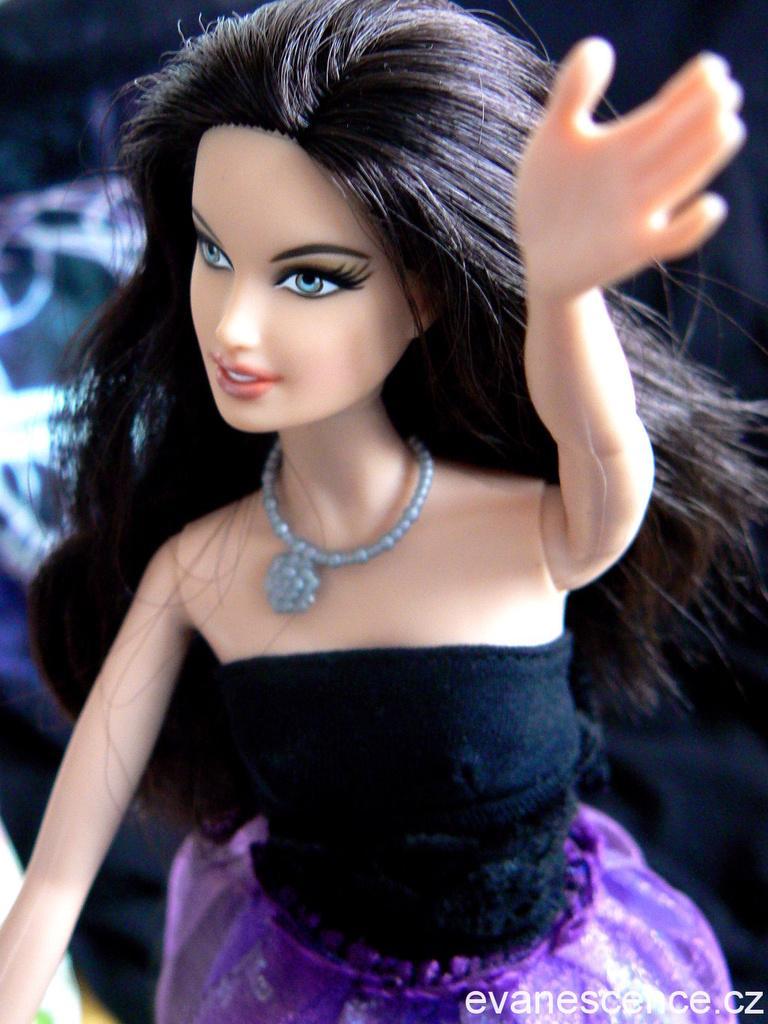In one or two sentences, can you explain what this image depicts? In this image I can see a barbie doll wearing a purple color dress facing towards the left.  